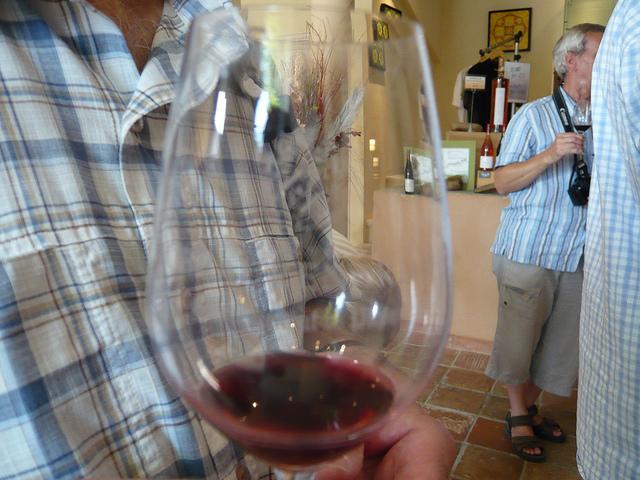Do you see someone holding a camera?
Concise answer only. Yes. Is that man wearing sandals?
Quick response, please. Yes. What color is the wine?
Answer briefly. Red. 